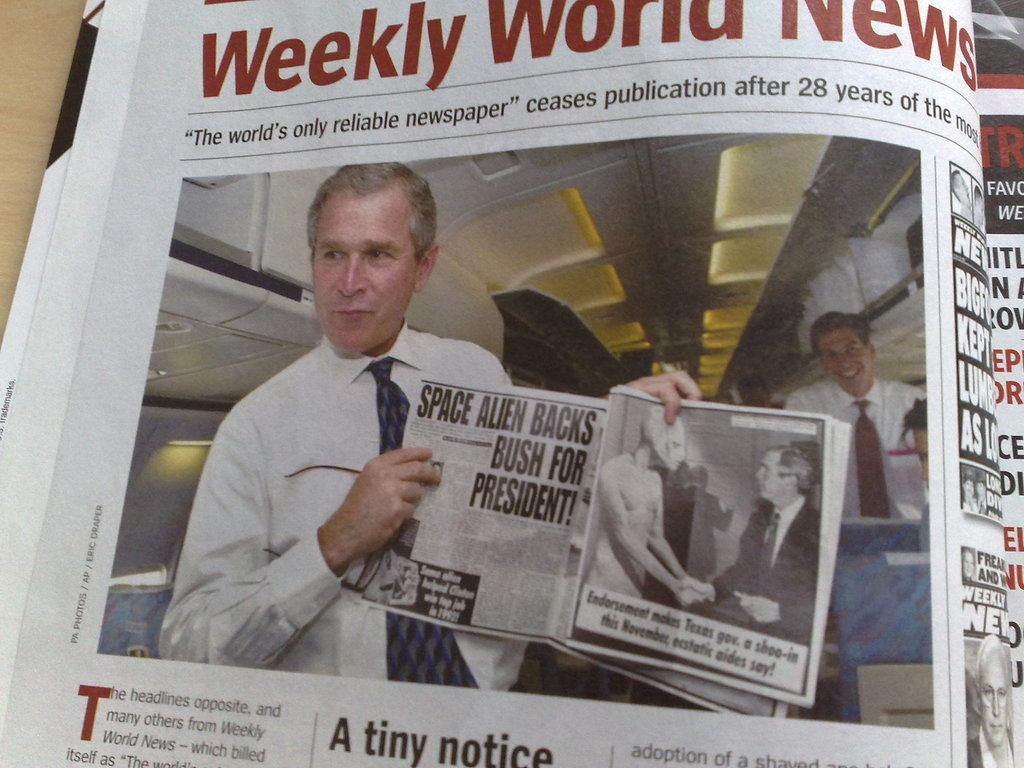Describe this image in one or two sentences. In this image we can see picture of a newspaper, in the newspaper we can see a photograph of George W Bush and some text written on it. 